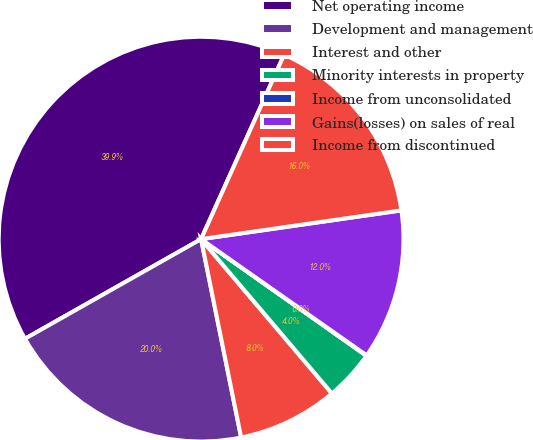Convert chart to OTSL. <chart><loc_0><loc_0><loc_500><loc_500><pie_chart><fcel>Net operating income<fcel>Development and management<fcel>Interest and other<fcel>Minority interests in property<fcel>Income from unconsolidated<fcel>Gains(losses) on sales of real<fcel>Income from discontinued<nl><fcel>39.93%<fcel>19.98%<fcel>8.02%<fcel>4.03%<fcel>0.04%<fcel>12.01%<fcel>16.0%<nl></chart> 